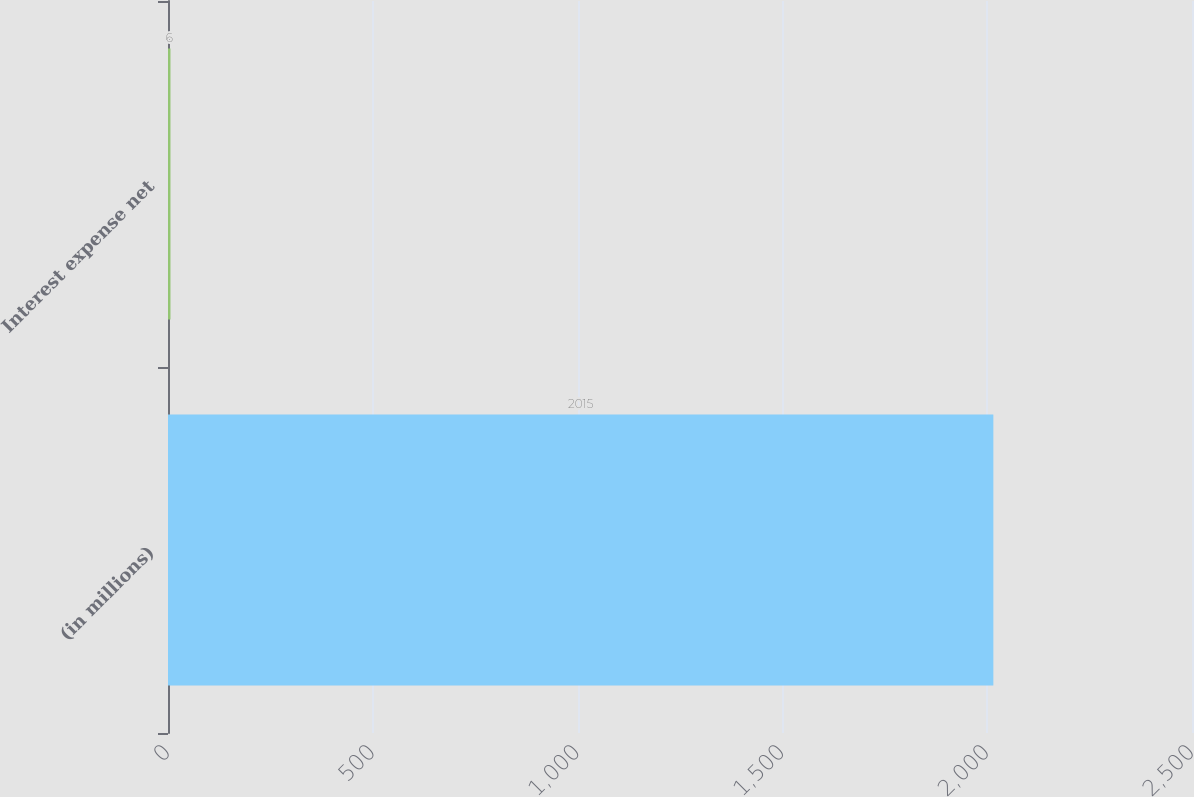Convert chart. <chart><loc_0><loc_0><loc_500><loc_500><bar_chart><fcel>(in millions)<fcel>Interest expense net<nl><fcel>2015<fcel>6<nl></chart> 